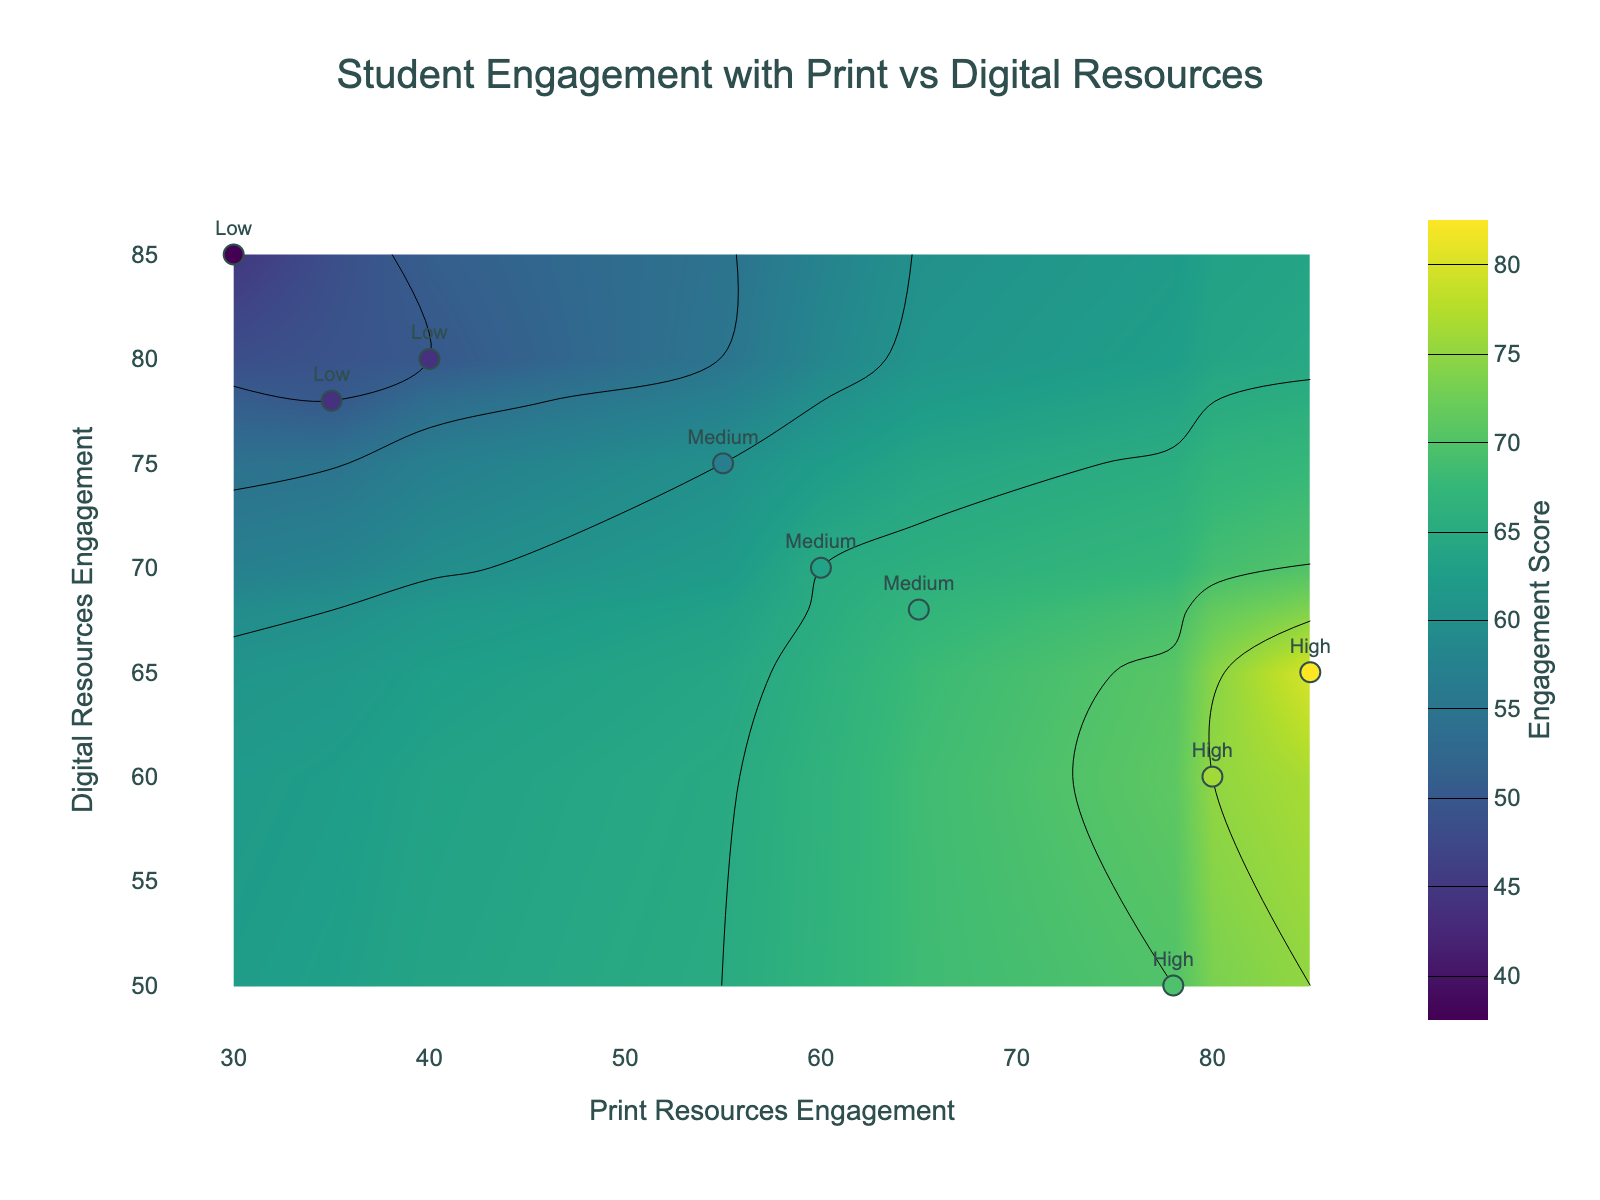What's the title of the figure? The title of the figure is located at the top center of the plot and usually summarizes the primary objective or relationship being displayed.
Answer: Student Engagement with Print vs Digital Resources What are the axis titles of the figure? The axis titles are located along the horizontal (x-axis) and vertical (y-axis) axes and describe the variables plotted against each axis.
Answer: Print Resources Engagement (x-axis) and Digital Resources Engagement (y-axis) How many high-performing students are represented in the plot? High-performing students are labeled "High" in the scatter plot portion of the figure. By counting the labeled points, we find there are three instances of "High."
Answer: 3 Which student performance tier has the widest range of engagement scores? By examining the distribution of engagement scores for each performance tier labeled in the scatter plot, we can see the variability and compare ranges. High-performance scores range from 70 to 80, Medium-performance from 60 to 67, Low-performance from 45 to 50. The High-tier has the widest range (70-80).
Answer: High At which point do students have high print engagement but low digital engagement? A high print engagement score combined with a low digital engagement score can be identified by finding the point where the x-axis value is high and the y-axis value is low. One example is the point with Print=78 and Digital=50.
Answer: Print = 78, Digital = 50 Which student performance tier tends to engage more with digital resources compared to print resources? To determine this, look at the labels where digital resource engagement (y-axis) is higher than print resource engagement (x-axis). From the plot, "Low" performance tier consistently displays higher digital engagement values compared to their print engagement values.
Answer: Low What is the engagement score of the student with 85 print and 65 digital engagement? Locate the point in the scatter plot corresponding to these engagement values (85 print, 65 digital); the engagement score is displayed as color intensity or can be directly read.
Answer: 80 Between print and digital resources, which one shows more variability in engagement scores for medium-performing students? To find this, compare the spread of data points along the x-axis (print) verses the y-axis (digital) for the "Medium" performance tier. Medium students have a print engagement range of 55-65 and digital range of 68-75. Print resources show a broader range (10 units) compared to digital resources (7 units).
Answer: Print resources What's the difference in engagement scores between the highest and lowest engaging high-performing students? For this, find the engagement scores for high-performing students, the highest is 80 (Print=85, Digital=65), and the lowest is 70 (Print=78, Digital=50). The difference is 80 - 70 = 10.
Answer: 10 